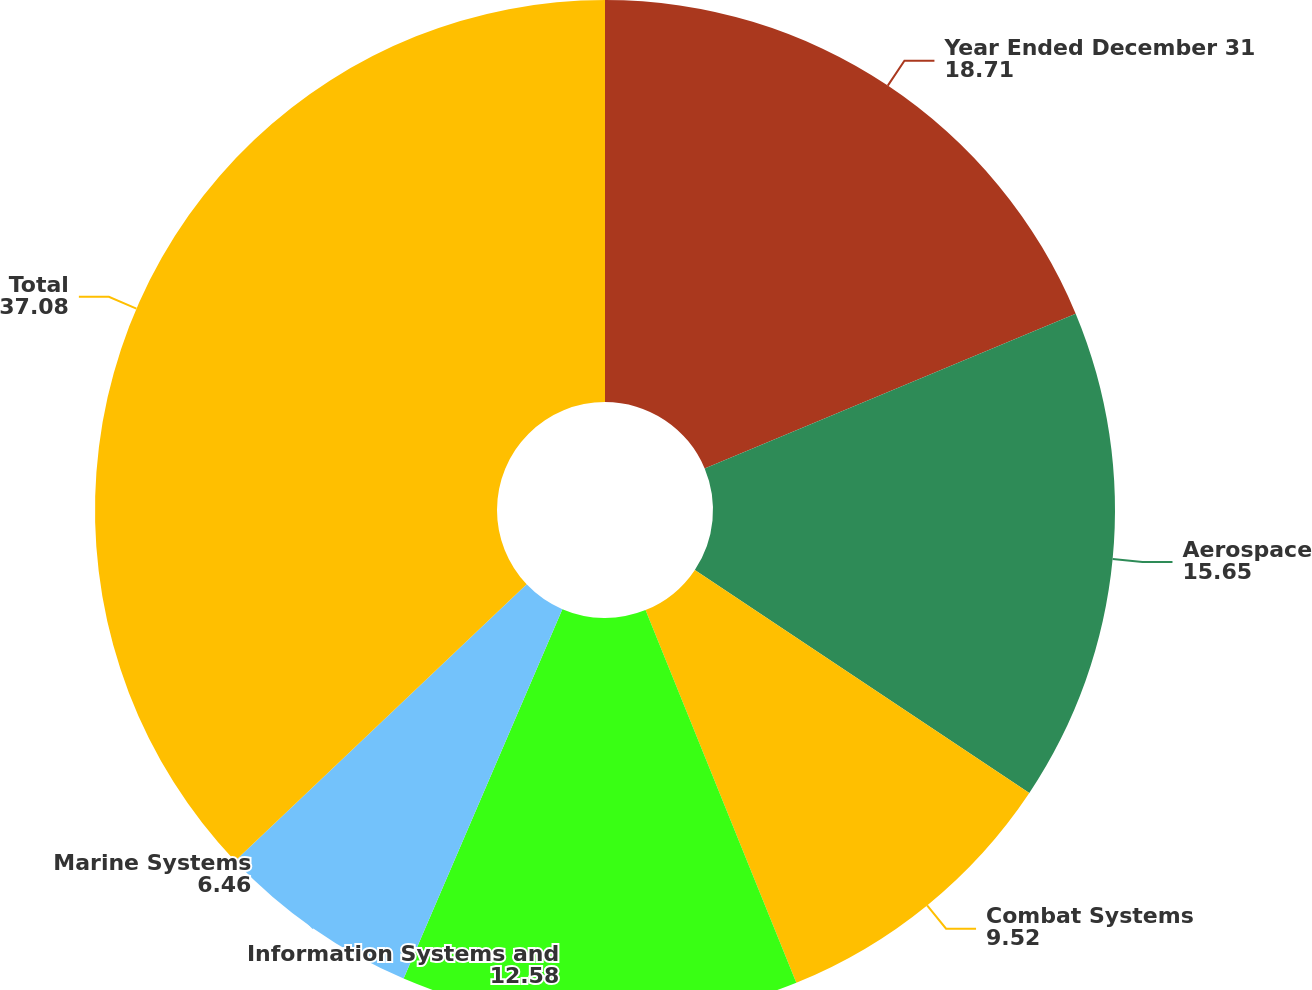<chart> <loc_0><loc_0><loc_500><loc_500><pie_chart><fcel>Year Ended December 31<fcel>Aerospace<fcel>Combat Systems<fcel>Information Systems and<fcel>Marine Systems<fcel>Total<nl><fcel>18.71%<fcel>15.65%<fcel>9.52%<fcel>12.58%<fcel>6.46%<fcel>37.08%<nl></chart> 